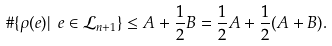Convert formula to latex. <formula><loc_0><loc_0><loc_500><loc_500>\# \{ \rho ( e ) | \ e \in { \mathcal { L } } _ { n + 1 } \} \leq A + \frac { 1 } { 2 } B = \frac { 1 } { 2 } A + \frac { 1 } { 2 } ( A + B ) .</formula> 